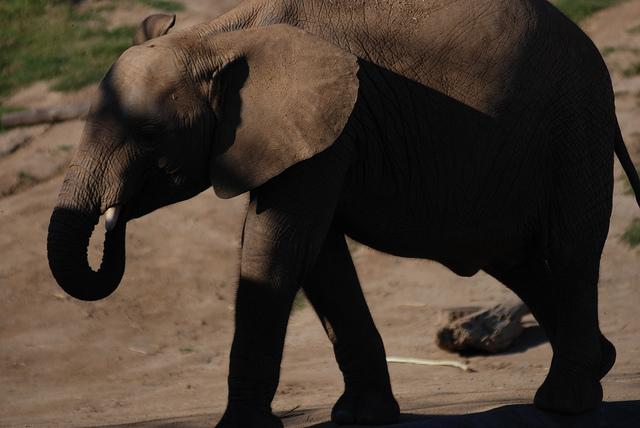Is the elephant in his natural habitat?
Quick response, please. No. Is this a female elephant?
Be succinct. Yes. Is this animal real?
Give a very brief answer. Yes. Is this a wild animal?
Concise answer only. Yes. Are there trees in this picture?
Give a very brief answer. No. How many elephants are there?
Answer briefly. 1. Are these elephants stampeding?
Short answer required. No. What color is the animal?
Concise answer only. Gray. Is this a baby elephant?
Keep it brief. Yes. What kind of animal is this?
Give a very brief answer. Elephant. 